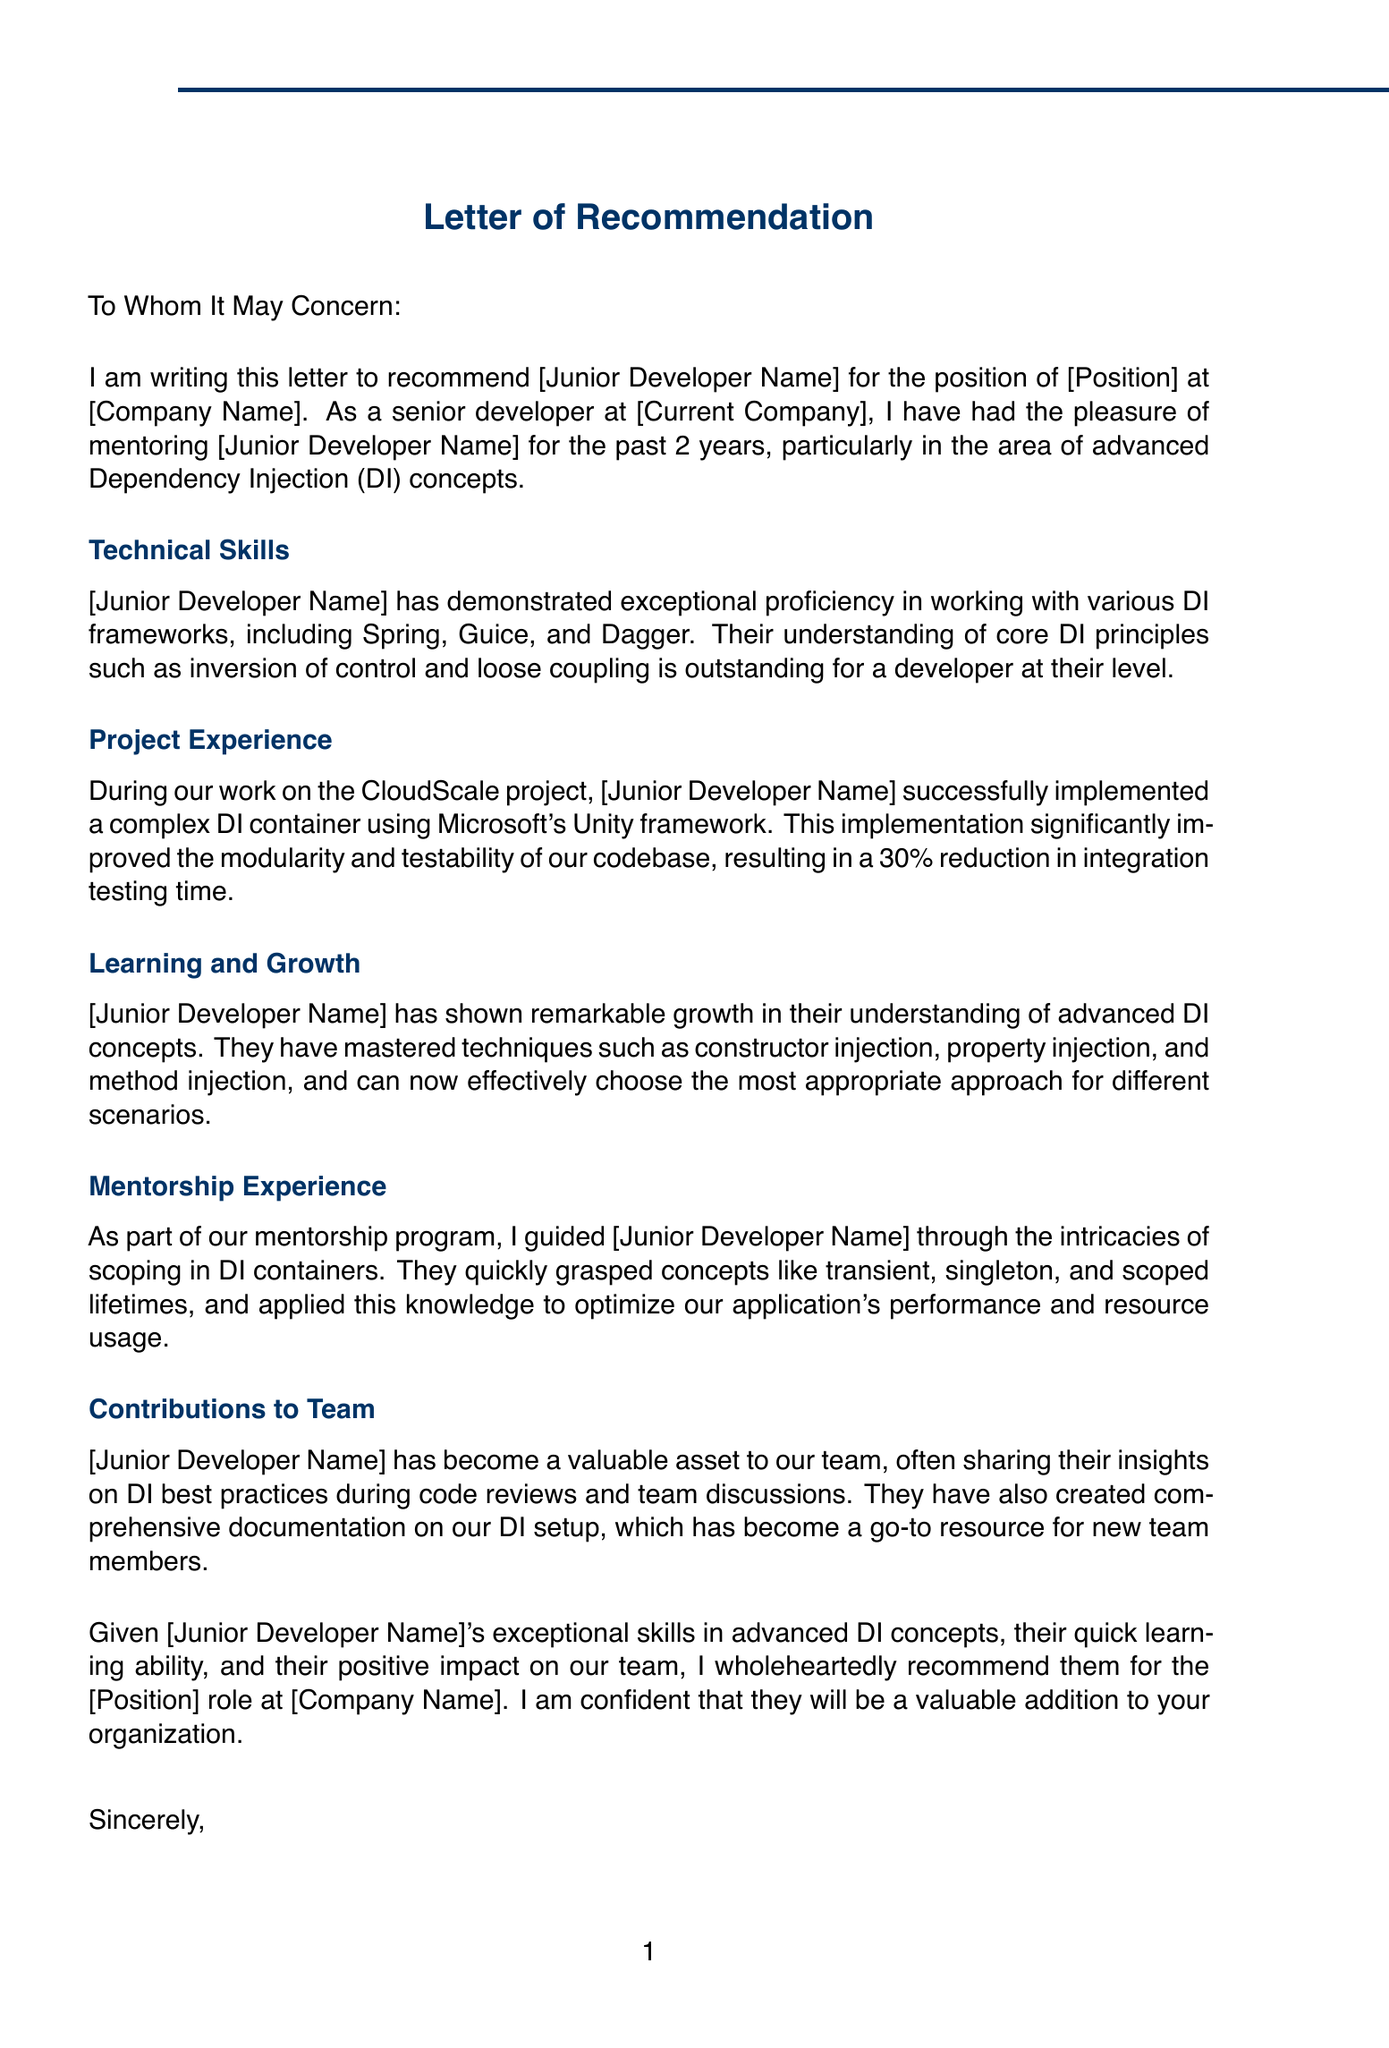To Whom It May Concern: This phrase indicates the recipient of the letter.
Answer: To Whom It May Concern: What is the recommended position for the junior developer? The position is specified in the letter as a recommendation for a certain role.
Answer: [Position] Who is the mentor of the junior developer? The mentor is identified in the letter, providing context about the recommendation.
Answer: [Your Name] How many years has the junior developer been mentored? The duration of the mentorship is highlighted in the introduction.
Answer: 2 What project is mentioned in the letter? The letter references a specific project that showcases the junior developer's experience.
Answer: CloudScale Which DI framework did the junior developer use? The implementation details include the framework utilized by the junior developer during their project work.
Answer: Microsoft Unity What was the percentage reduction in integration testing time? This is a measurable outcome of the junior developer's project contributions.
Answer: 30% What advanced DI technique did the junior developer master? This question asks specifically about the skills acquired by the junior developer during mentorship.
Answer: constructor injection What was the main focus of the mentorship program? The focus areas are outlined in the letter, summarizing the mentorship's content.
Answer: Dependency Injection principles How has the junior developer contributed to the team? The letter outlines contributions made by the junior developer, highlighting their impact.
Answer: documentation on our DI setup 